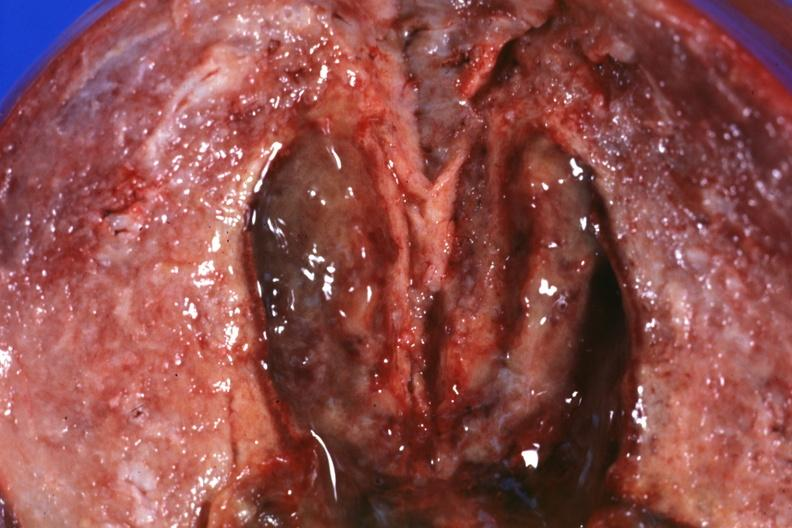what is present?
Answer the question using a single word or phrase. Endometritis 